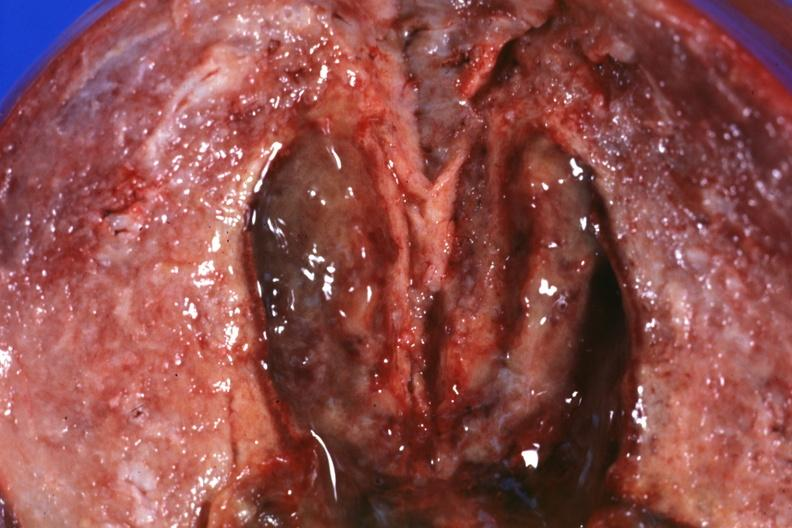what is present?
Answer the question using a single word or phrase. Endometritis 